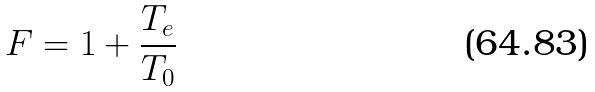Convert formula to latex. <formula><loc_0><loc_0><loc_500><loc_500>F = 1 + \frac { T _ { e } } { T _ { 0 } }</formula> 